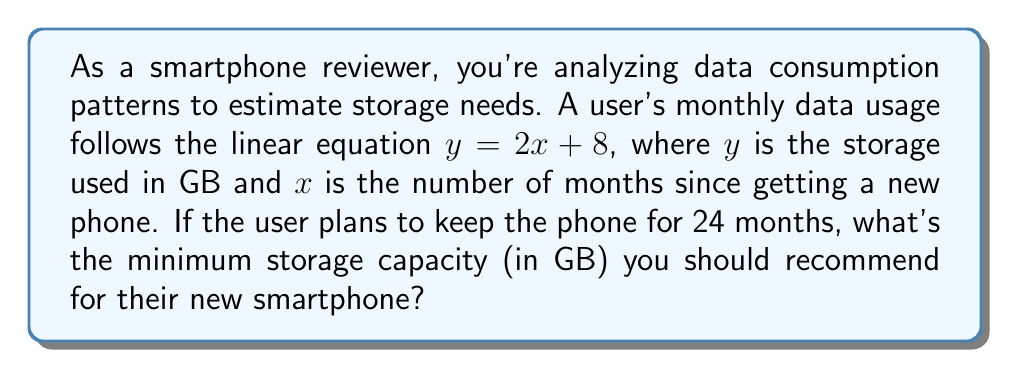Help me with this question. 1. The linear equation given is $y = 2x + 8$, where:
   $y$ = storage used in GB
   $x$ = number of months since getting the new phone

2. We need to find the storage used after 24 months, so we substitute $x = 24$:
   $y = 2(24) + 8$

3. Simplify:
   $y = 48 + 8 = 56$

4. This means after 24 months, the user will have used 56 GB of storage.

5. However, we need to account for:
   a) The operating system and pre-installed apps (typically 10-15 GB)
   b) Some buffer space for smooth operation (about 10% of total capacity)

6. Let's assume 15 GB for the OS and pre-installed apps:
   $56 + 15 = 71$ GB

7. To add a 10% buffer, we multiply by 1.1:
   $71 * 1.1 = 78.1$ GB

8. Round up to the nearest standard storage option, which is typically 128 GB.
Answer: 128 GB 